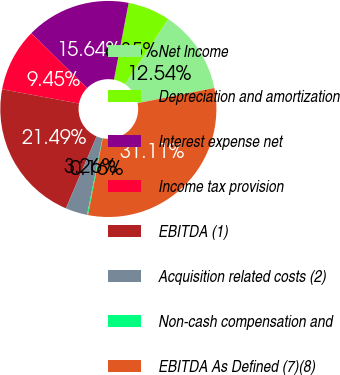Convert chart. <chart><loc_0><loc_0><loc_500><loc_500><pie_chart><fcel>Net Income<fcel>Depreciation and amortization<fcel>Interest expense net<fcel>Income tax provision<fcel>EBITDA (1)<fcel>Acquisition related costs (2)<fcel>Non-cash compensation and<fcel>EBITDA As Defined (7)(8)<nl><fcel>12.54%<fcel>6.35%<fcel>15.64%<fcel>9.45%<fcel>21.49%<fcel>3.26%<fcel>0.16%<fcel>31.11%<nl></chart> 